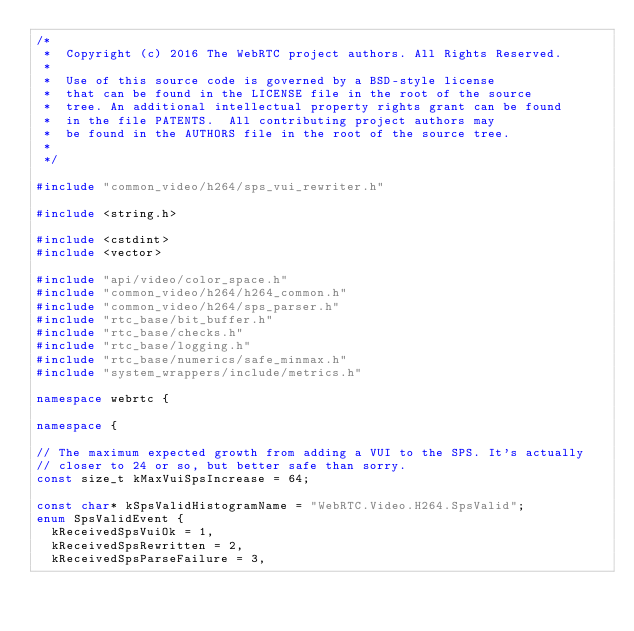<code> <loc_0><loc_0><loc_500><loc_500><_C++_>/*
 *  Copyright (c) 2016 The WebRTC project authors. All Rights Reserved.
 *
 *  Use of this source code is governed by a BSD-style license
 *  that can be found in the LICENSE file in the root of the source
 *  tree. An additional intellectual property rights grant can be found
 *  in the file PATENTS.  All contributing project authors may
 *  be found in the AUTHORS file in the root of the source tree.
 *
 */

#include "common_video/h264/sps_vui_rewriter.h"

#include <string.h>

#include <cstdint>
#include <vector>

#include "api/video/color_space.h"
#include "common_video/h264/h264_common.h"
#include "common_video/h264/sps_parser.h"
#include "rtc_base/bit_buffer.h"
#include "rtc_base/checks.h"
#include "rtc_base/logging.h"
#include "rtc_base/numerics/safe_minmax.h"
#include "system_wrappers/include/metrics.h"

namespace webrtc {

namespace {

// The maximum expected growth from adding a VUI to the SPS. It's actually
// closer to 24 or so, but better safe than sorry.
const size_t kMaxVuiSpsIncrease = 64;

const char* kSpsValidHistogramName = "WebRTC.Video.H264.SpsValid";
enum SpsValidEvent {
  kReceivedSpsVuiOk = 1,
  kReceivedSpsRewritten = 2,
  kReceivedSpsParseFailure = 3,</code> 